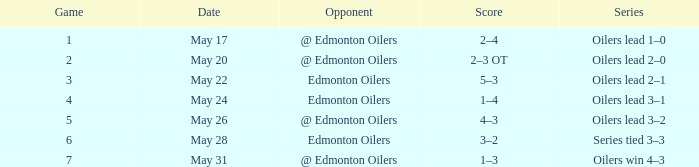In a game less than 7, what was the score when the oilers' rival faced them with the oilers leading the series 3-2? 4–3. 